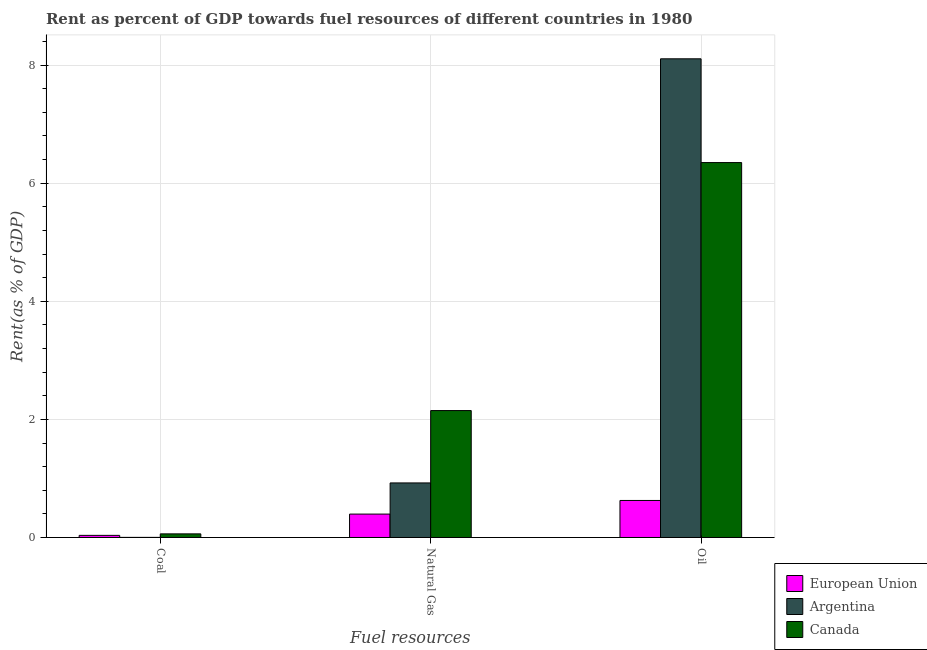How many groups of bars are there?
Provide a succinct answer. 3. How many bars are there on the 1st tick from the right?
Ensure brevity in your answer.  3. What is the label of the 3rd group of bars from the left?
Make the answer very short. Oil. What is the rent towards natural gas in Canada?
Keep it short and to the point. 2.15. Across all countries, what is the maximum rent towards oil?
Ensure brevity in your answer.  8.11. Across all countries, what is the minimum rent towards oil?
Your answer should be compact. 0.63. What is the total rent towards natural gas in the graph?
Provide a short and direct response. 3.47. What is the difference between the rent towards coal in European Union and that in Canada?
Keep it short and to the point. -0.03. What is the difference between the rent towards oil in European Union and the rent towards coal in Canada?
Your answer should be very brief. 0.57. What is the average rent towards oil per country?
Give a very brief answer. 5.03. What is the difference between the rent towards oil and rent towards coal in Canada?
Provide a succinct answer. 6.29. What is the ratio of the rent towards coal in Argentina to that in European Union?
Provide a short and direct response. 0.05. Is the rent towards oil in Argentina less than that in European Union?
Your response must be concise. No. Is the difference between the rent towards coal in Argentina and Canada greater than the difference between the rent towards oil in Argentina and Canada?
Provide a succinct answer. No. What is the difference between the highest and the second highest rent towards oil?
Offer a very short reply. 1.76. What is the difference between the highest and the lowest rent towards oil?
Keep it short and to the point. 7.48. In how many countries, is the rent towards oil greater than the average rent towards oil taken over all countries?
Offer a very short reply. 2. What does the 2nd bar from the right in Coal represents?
Your answer should be very brief. Argentina. How many countries are there in the graph?
Ensure brevity in your answer.  3. Does the graph contain grids?
Provide a short and direct response. Yes. Where does the legend appear in the graph?
Give a very brief answer. Bottom right. How many legend labels are there?
Offer a terse response. 3. How are the legend labels stacked?
Make the answer very short. Vertical. What is the title of the graph?
Your answer should be compact. Rent as percent of GDP towards fuel resources of different countries in 1980. What is the label or title of the X-axis?
Give a very brief answer. Fuel resources. What is the label or title of the Y-axis?
Offer a terse response. Rent(as % of GDP). What is the Rent(as % of GDP) of European Union in Coal?
Provide a succinct answer. 0.04. What is the Rent(as % of GDP) in Argentina in Coal?
Provide a short and direct response. 0. What is the Rent(as % of GDP) of Canada in Coal?
Ensure brevity in your answer.  0.06. What is the Rent(as % of GDP) in European Union in Natural Gas?
Your answer should be very brief. 0.4. What is the Rent(as % of GDP) of Argentina in Natural Gas?
Your response must be concise. 0.92. What is the Rent(as % of GDP) of Canada in Natural Gas?
Your answer should be very brief. 2.15. What is the Rent(as % of GDP) in European Union in Oil?
Offer a very short reply. 0.63. What is the Rent(as % of GDP) of Argentina in Oil?
Offer a very short reply. 8.11. What is the Rent(as % of GDP) in Canada in Oil?
Keep it short and to the point. 6.35. Across all Fuel resources, what is the maximum Rent(as % of GDP) of European Union?
Your answer should be very brief. 0.63. Across all Fuel resources, what is the maximum Rent(as % of GDP) of Argentina?
Your answer should be very brief. 8.11. Across all Fuel resources, what is the maximum Rent(as % of GDP) in Canada?
Give a very brief answer. 6.35. Across all Fuel resources, what is the minimum Rent(as % of GDP) of European Union?
Keep it short and to the point. 0.04. Across all Fuel resources, what is the minimum Rent(as % of GDP) in Argentina?
Offer a terse response. 0. Across all Fuel resources, what is the minimum Rent(as % of GDP) in Canada?
Ensure brevity in your answer.  0.06. What is the total Rent(as % of GDP) of European Union in the graph?
Provide a short and direct response. 1.06. What is the total Rent(as % of GDP) of Argentina in the graph?
Provide a short and direct response. 9.03. What is the total Rent(as % of GDP) of Canada in the graph?
Provide a succinct answer. 8.56. What is the difference between the Rent(as % of GDP) of European Union in Coal and that in Natural Gas?
Give a very brief answer. -0.36. What is the difference between the Rent(as % of GDP) of Argentina in Coal and that in Natural Gas?
Keep it short and to the point. -0.92. What is the difference between the Rent(as % of GDP) in Canada in Coal and that in Natural Gas?
Give a very brief answer. -2.09. What is the difference between the Rent(as % of GDP) in European Union in Coal and that in Oil?
Your response must be concise. -0.59. What is the difference between the Rent(as % of GDP) in Argentina in Coal and that in Oil?
Offer a very short reply. -8.11. What is the difference between the Rent(as % of GDP) in Canada in Coal and that in Oil?
Give a very brief answer. -6.29. What is the difference between the Rent(as % of GDP) of European Union in Natural Gas and that in Oil?
Your response must be concise. -0.23. What is the difference between the Rent(as % of GDP) of Argentina in Natural Gas and that in Oil?
Offer a very short reply. -7.18. What is the difference between the Rent(as % of GDP) of Canada in Natural Gas and that in Oil?
Provide a short and direct response. -4.2. What is the difference between the Rent(as % of GDP) of European Union in Coal and the Rent(as % of GDP) of Argentina in Natural Gas?
Your answer should be very brief. -0.89. What is the difference between the Rent(as % of GDP) in European Union in Coal and the Rent(as % of GDP) in Canada in Natural Gas?
Offer a very short reply. -2.11. What is the difference between the Rent(as % of GDP) of Argentina in Coal and the Rent(as % of GDP) of Canada in Natural Gas?
Keep it short and to the point. -2.15. What is the difference between the Rent(as % of GDP) of European Union in Coal and the Rent(as % of GDP) of Argentina in Oil?
Your response must be concise. -8.07. What is the difference between the Rent(as % of GDP) in European Union in Coal and the Rent(as % of GDP) in Canada in Oil?
Your answer should be compact. -6.31. What is the difference between the Rent(as % of GDP) in Argentina in Coal and the Rent(as % of GDP) in Canada in Oil?
Your answer should be very brief. -6.35. What is the difference between the Rent(as % of GDP) in European Union in Natural Gas and the Rent(as % of GDP) in Argentina in Oil?
Provide a succinct answer. -7.71. What is the difference between the Rent(as % of GDP) in European Union in Natural Gas and the Rent(as % of GDP) in Canada in Oil?
Provide a short and direct response. -5.95. What is the difference between the Rent(as % of GDP) in Argentina in Natural Gas and the Rent(as % of GDP) in Canada in Oil?
Your answer should be very brief. -5.43. What is the average Rent(as % of GDP) in European Union per Fuel resources?
Your answer should be compact. 0.35. What is the average Rent(as % of GDP) in Argentina per Fuel resources?
Your response must be concise. 3.01. What is the average Rent(as % of GDP) in Canada per Fuel resources?
Your answer should be compact. 2.85. What is the difference between the Rent(as % of GDP) in European Union and Rent(as % of GDP) in Argentina in Coal?
Your answer should be very brief. 0.03. What is the difference between the Rent(as % of GDP) in European Union and Rent(as % of GDP) in Canada in Coal?
Make the answer very short. -0.03. What is the difference between the Rent(as % of GDP) in Argentina and Rent(as % of GDP) in Canada in Coal?
Your answer should be very brief. -0.06. What is the difference between the Rent(as % of GDP) of European Union and Rent(as % of GDP) of Argentina in Natural Gas?
Ensure brevity in your answer.  -0.53. What is the difference between the Rent(as % of GDP) in European Union and Rent(as % of GDP) in Canada in Natural Gas?
Ensure brevity in your answer.  -1.75. What is the difference between the Rent(as % of GDP) in Argentina and Rent(as % of GDP) in Canada in Natural Gas?
Your answer should be very brief. -1.23. What is the difference between the Rent(as % of GDP) of European Union and Rent(as % of GDP) of Argentina in Oil?
Offer a very short reply. -7.48. What is the difference between the Rent(as % of GDP) of European Union and Rent(as % of GDP) of Canada in Oil?
Your answer should be very brief. -5.72. What is the difference between the Rent(as % of GDP) in Argentina and Rent(as % of GDP) in Canada in Oil?
Your answer should be compact. 1.76. What is the ratio of the Rent(as % of GDP) of European Union in Coal to that in Natural Gas?
Your answer should be compact. 0.09. What is the ratio of the Rent(as % of GDP) in Argentina in Coal to that in Natural Gas?
Your response must be concise. 0. What is the ratio of the Rent(as % of GDP) of Canada in Coal to that in Natural Gas?
Provide a short and direct response. 0.03. What is the ratio of the Rent(as % of GDP) in European Union in Coal to that in Oil?
Provide a succinct answer. 0.06. What is the ratio of the Rent(as % of GDP) of Argentina in Coal to that in Oil?
Offer a terse response. 0. What is the ratio of the Rent(as % of GDP) of Canada in Coal to that in Oil?
Your answer should be very brief. 0.01. What is the ratio of the Rent(as % of GDP) of European Union in Natural Gas to that in Oil?
Offer a very short reply. 0.63. What is the ratio of the Rent(as % of GDP) of Argentina in Natural Gas to that in Oil?
Offer a very short reply. 0.11. What is the ratio of the Rent(as % of GDP) of Canada in Natural Gas to that in Oil?
Provide a succinct answer. 0.34. What is the difference between the highest and the second highest Rent(as % of GDP) of European Union?
Offer a very short reply. 0.23. What is the difference between the highest and the second highest Rent(as % of GDP) in Argentina?
Give a very brief answer. 7.18. What is the difference between the highest and the second highest Rent(as % of GDP) in Canada?
Provide a short and direct response. 4.2. What is the difference between the highest and the lowest Rent(as % of GDP) of European Union?
Your response must be concise. 0.59. What is the difference between the highest and the lowest Rent(as % of GDP) in Argentina?
Make the answer very short. 8.11. What is the difference between the highest and the lowest Rent(as % of GDP) in Canada?
Your answer should be very brief. 6.29. 